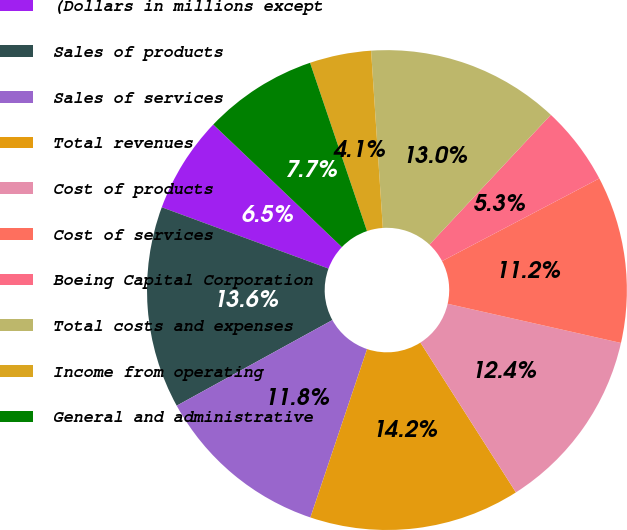<chart> <loc_0><loc_0><loc_500><loc_500><pie_chart><fcel>(Dollars in millions except<fcel>Sales of products<fcel>Sales of services<fcel>Total revenues<fcel>Cost of products<fcel>Cost of services<fcel>Boeing Capital Corporation<fcel>Total costs and expenses<fcel>Income from operating<fcel>General and administrative<nl><fcel>6.51%<fcel>13.61%<fcel>11.83%<fcel>14.2%<fcel>12.43%<fcel>11.24%<fcel>5.33%<fcel>13.02%<fcel>4.14%<fcel>7.69%<nl></chart> 